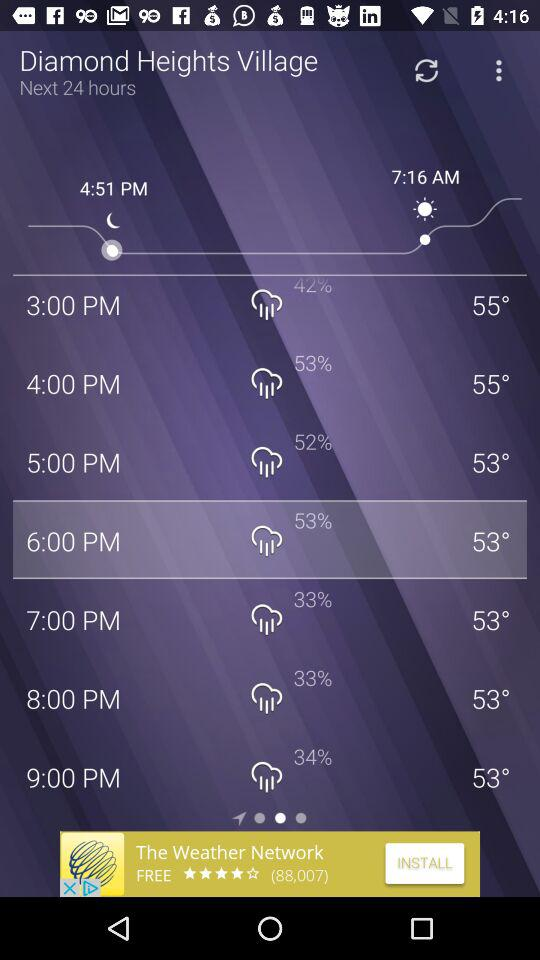What is the location? The location is Diamond Heights Village. 